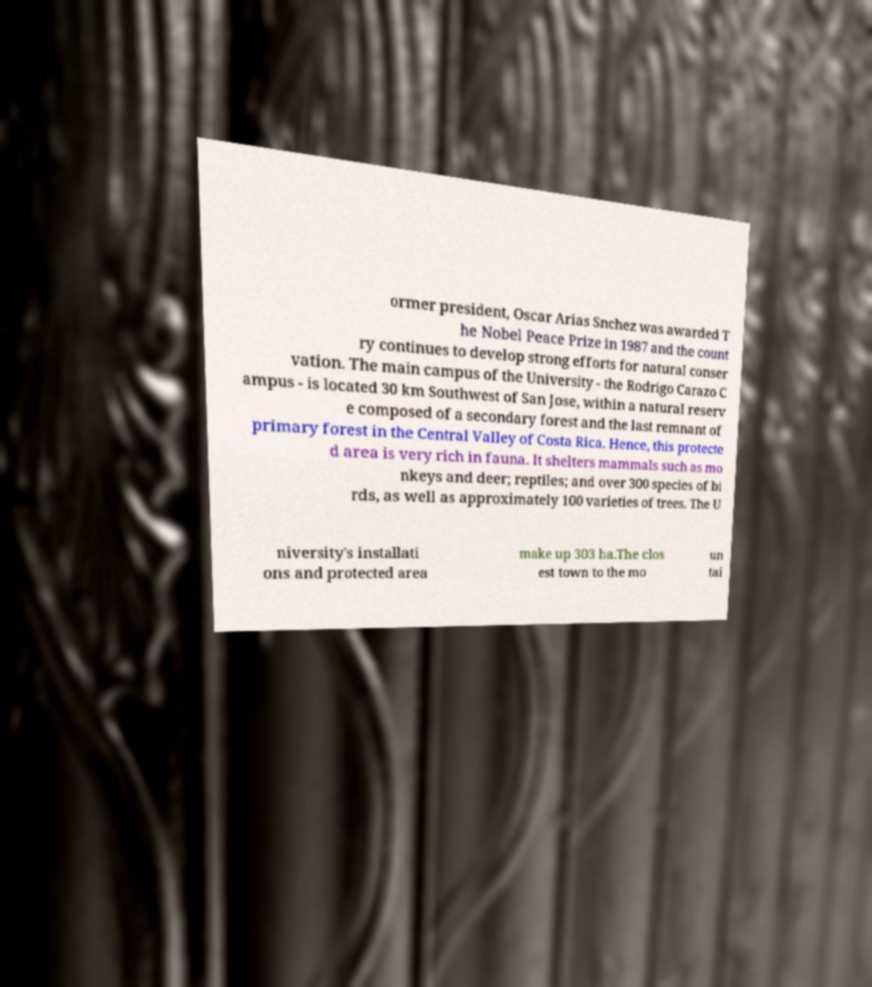Could you extract and type out the text from this image? ormer president, Oscar Arias Snchez was awarded T he Nobel Peace Prize in 1987 and the count ry continues to develop strong efforts for natural conser vation. The main campus of the University - the Rodrigo Carazo C ampus - is located 30 km Southwest of San Jose, within a natural reserv e composed of a secondary forest and the last remnant of primary forest in the Central Valley of Costa Rica. Hence, this protecte d area is very rich in fauna. It shelters mammals such as mo nkeys and deer; reptiles; and over 300 species of bi rds, as well as approximately 100 varieties of trees. The U niversity's installati ons and protected area make up 303 ha.The clos est town to the mo un tai 